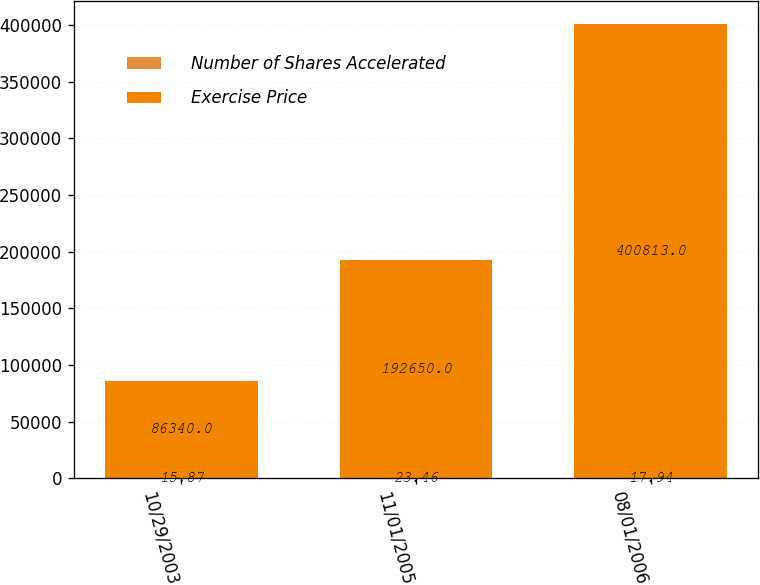Convert chart. <chart><loc_0><loc_0><loc_500><loc_500><stacked_bar_chart><ecel><fcel>10/29/2003<fcel>11/01/2005<fcel>08/01/2006<nl><fcel>Number of Shares Accelerated<fcel>15.87<fcel>23.46<fcel>17.94<nl><fcel>Exercise Price<fcel>86340<fcel>192650<fcel>400813<nl></chart> 